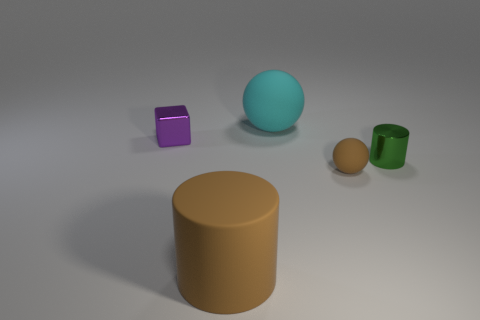Add 1 tiny cyan cylinders. How many objects exist? 6 Subtract all cylinders. How many objects are left? 3 Subtract 1 cylinders. How many cylinders are left? 1 Subtract all red cubes. Subtract all green cylinders. How many cubes are left? 1 Subtract all brown cylinders. How many brown balls are left? 1 Subtract all purple blocks. Subtract all small rubber balls. How many objects are left? 3 Add 1 tiny purple metal cubes. How many tiny purple metal cubes are left? 2 Add 4 cubes. How many cubes exist? 5 Subtract 1 brown spheres. How many objects are left? 4 